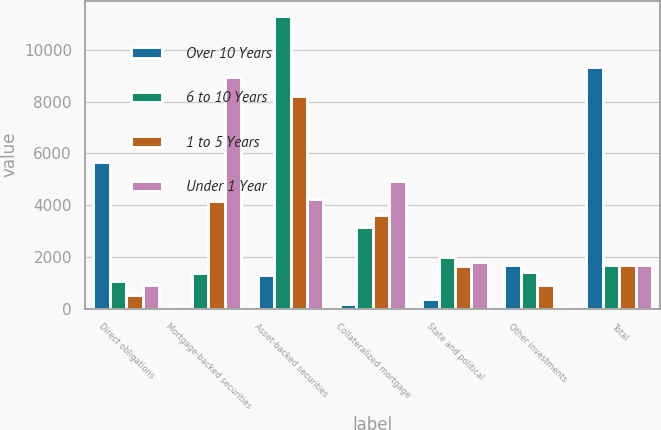Convert chart to OTSL. <chart><loc_0><loc_0><loc_500><loc_500><stacked_bar_chart><ecel><fcel>Direct obligations<fcel>Mortgage-backed securities<fcel>Asset-backed securities<fcel>Collateralized mortgage<fcel>State and political<fcel>Other investments<fcel>Total<nl><fcel>Over 10 Years<fcel>5683<fcel>116<fcel>1304<fcel>170<fcel>370<fcel>1686<fcel>9329<nl><fcel>6 to 10 Years<fcel>1072<fcel>1384<fcel>11321<fcel>3156<fcel>1997<fcel>1405<fcel>1686<nl><fcel>1 to 5 Years<fcel>520<fcel>4152<fcel>8223<fcel>3617<fcel>1644<fcel>906<fcel>1686<nl><fcel>Under 1 Year<fcel>906<fcel>8933<fcel>4221<fcel>4949<fcel>1802<fcel>44<fcel>1686<nl></chart> 